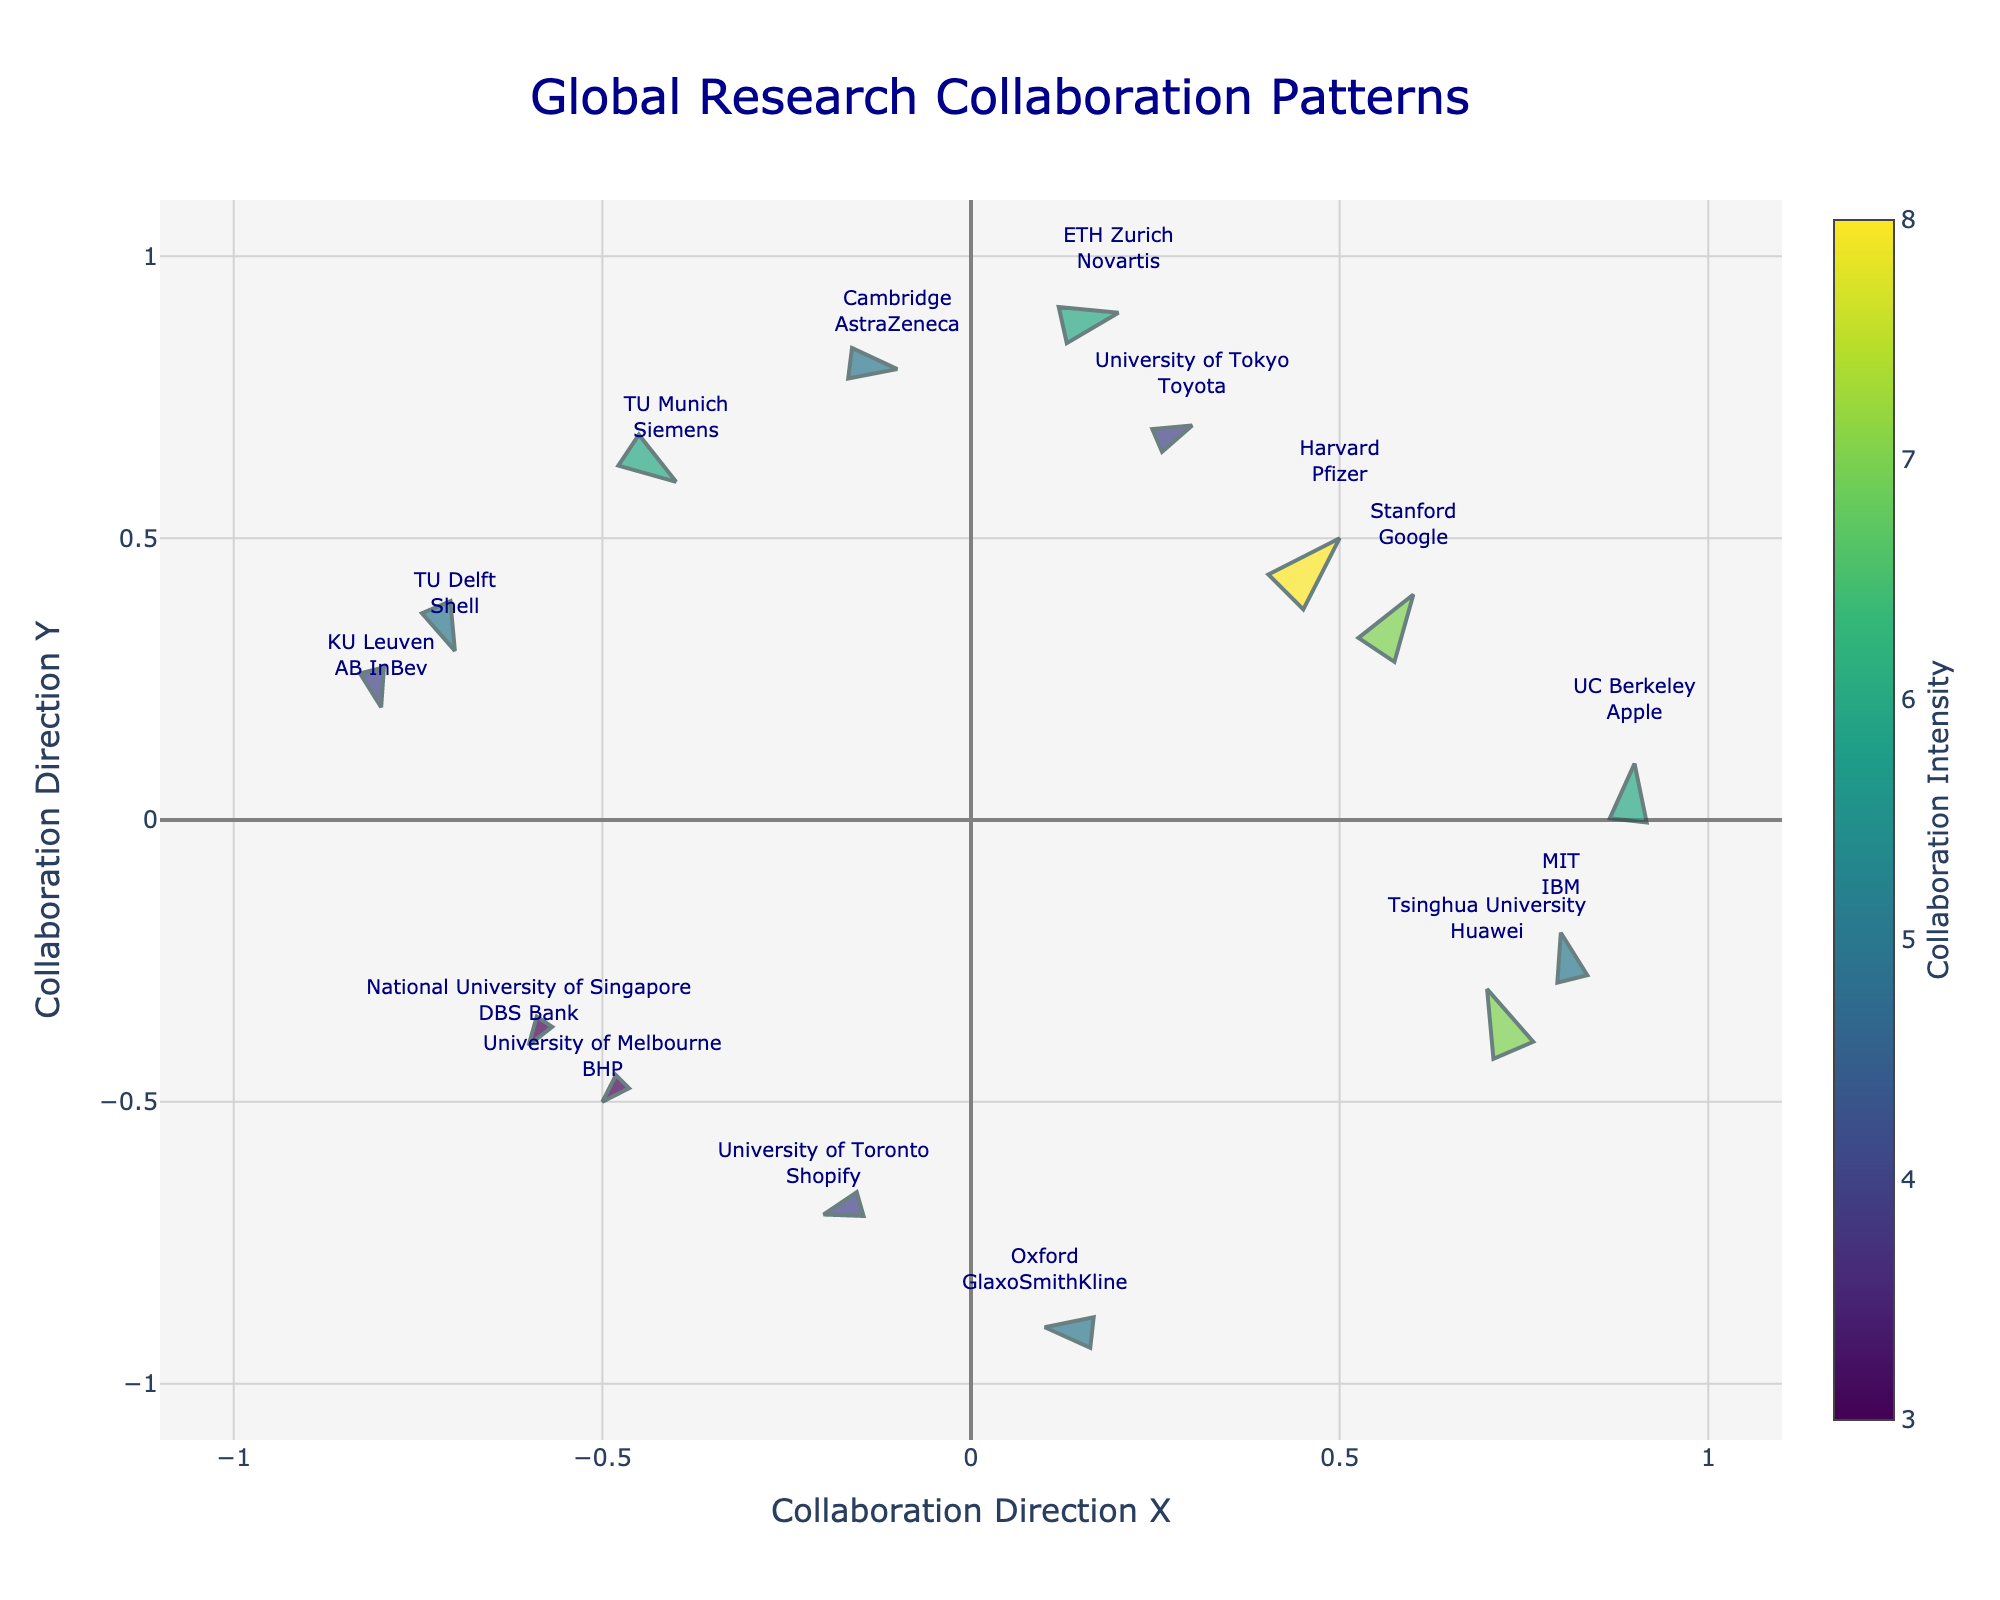How many unique university-corporation pairs are shown in the figure? The figure contains markers with text labels representing each university-corporation collaboration. By counting these unique labels, we see there are 15 pairs.
Answer: 15 What is the title of the figure? The title is located at the top center of the plot, typically in a larger and darker font. It reads "Global Research Collaboration Patterns."
Answer: Global Research Collaboration Patterns Which collaboration has the highest intensity? Look for the marker with the largest size since intensity is depicted through marker size, and then check the color scale or hover text to identify it. Harvard and Pfizer stand out with the highest intensity of 8.
Answer: Harvard and Pfizer Which university collaborates with a direction vector closest to the origin (0,0)? The direction vector closest to the origin (0,0) has the smallest Euclidean distance. Visually, we need to find the shortest arrows. The collaboration between National University of Singapore and DBS Bank with direction vector (-0.6, -0.4) is closest.
Answer: National University of Singapore and DBS Bank What is the range of collaboration intensity values? Analyze the color scale bar and the size of the markers. Each marker's size and color indicate intensity values specified in the color bar ranging from 3 to 8.
Answer: 3 to 8 Which collaboration has the largest negative x-direction? Examine the x-direction arrows and find the marker pointing furthest left. KU Leuven and AB InBev with a direction vector of (-0.8, 0.2) show the largest negative x-direction.
Answer: KU Leuven and AB InBev What are the coordinates of the collaboration with MIT and IBM? Find the marker labeled "MIT" and "IBM." The direction vector shown next to it is (0.8, -0.2).
Answer: (0.8, -0.2) Which collaboration's direction has an equal x and y component? Look for markers along lines y=x or y=-x. Harvard and Pfizer have equal x and y components with a direction vector of (0.5, 0.5).
Answer: Harvard and Pfizer Which pair shows the longest arrow? How do you determine it? Longer arrows represent higher intensity collaborations depicted by larger markers and longer vectors. Inspect visually or by checking data. One of the most extended visible arrows, UC Berkeley to Apple, with intensity 6 and vector (0.9, 0.1).
Answer: UC Berkeley and Apple 